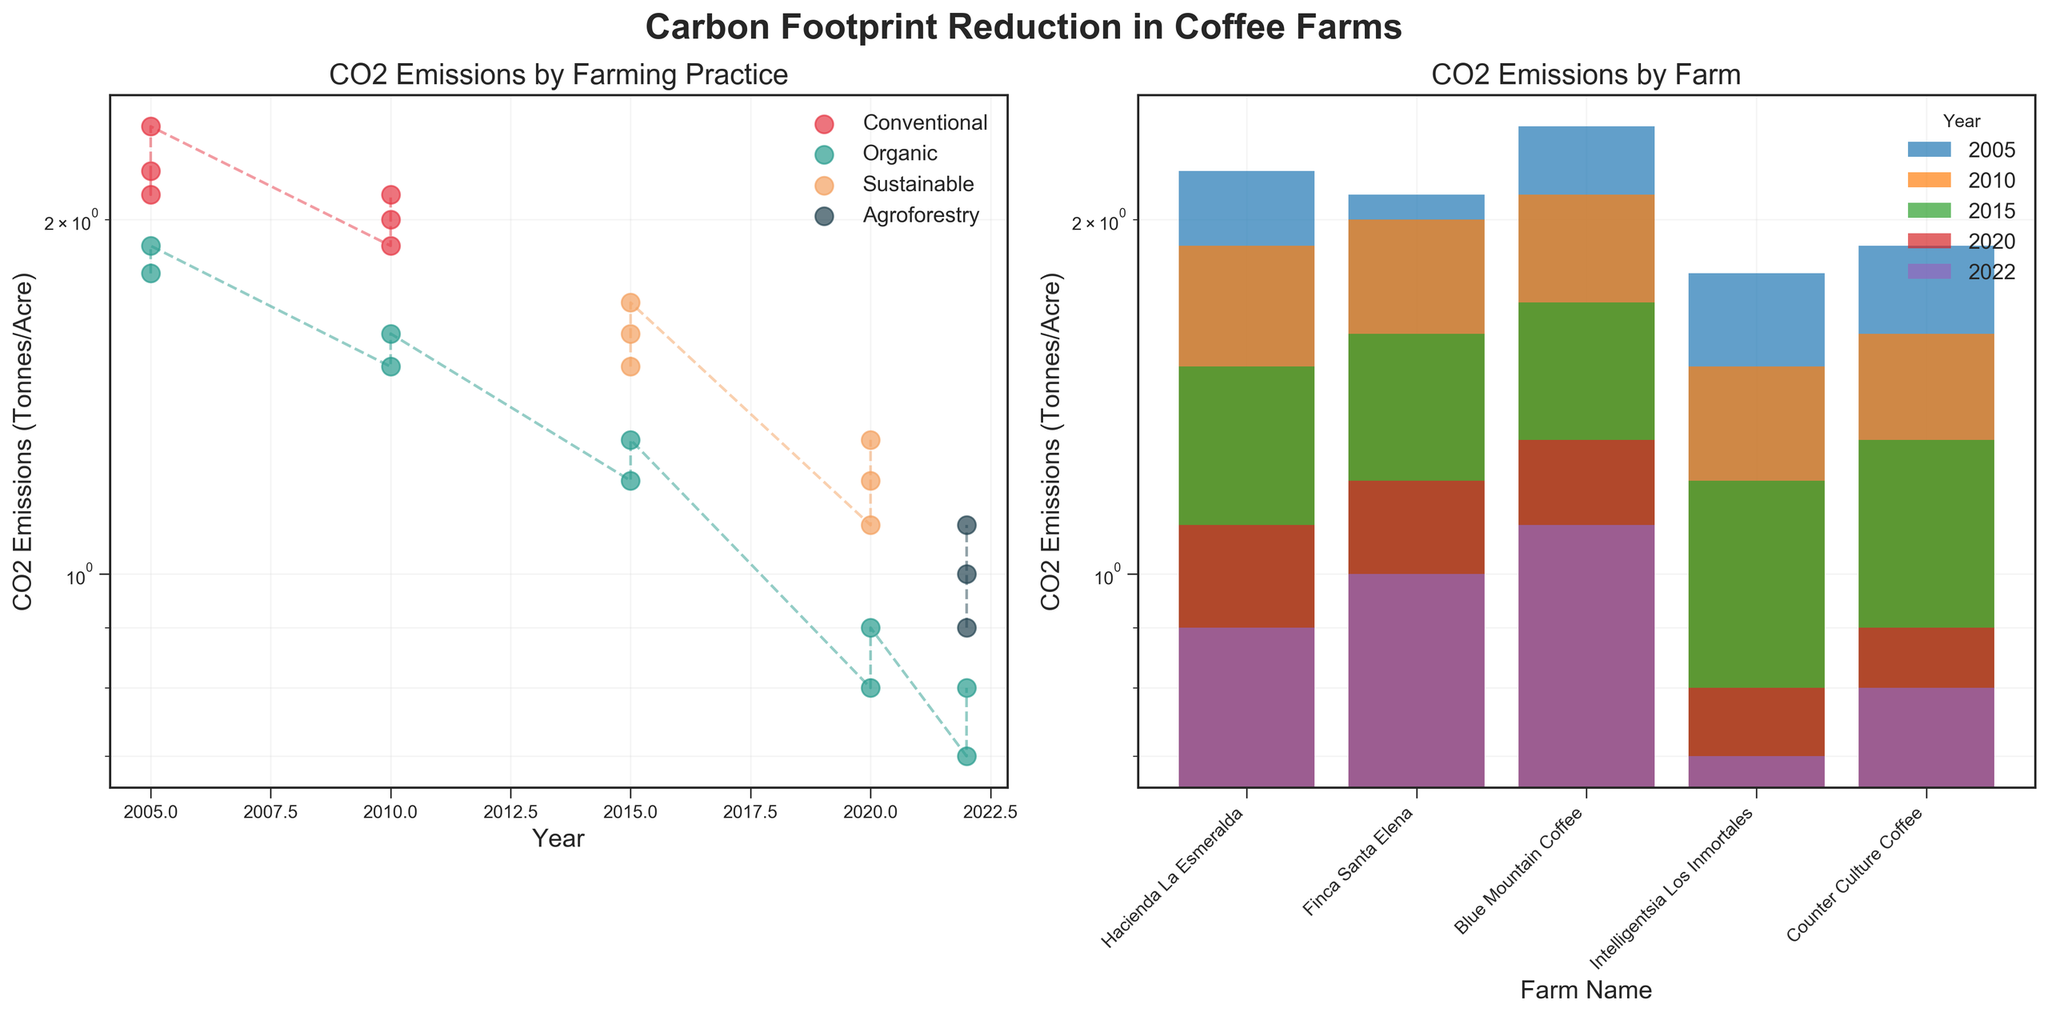What is the title of the left subplot? The title of the left subplot is "CO2 Emissions by Farming Practice," which indicates the CO2 emissions over the years categorized by different farming practices.
Answer: CO2 Emissions by Farming Practice Which farming practice consistently shows the lowest CO2 emissions in 2022? In 2022, 'Organic' farming practice consistently shows the lowest CO2 emissions, which can be observed by the position of the green dots and bars in the left and right subplots respectively.
Answer: Organic Between 2005 and 2022, which farming practice showed the most significant reduction in CO2 emissions? To find the farming practice with the most significant reduction, compare the initial and final values of CO2 emissions for each practice over the years. 'Conventional' and 'Sustainable' started higher but it's the 'Agroforestry' practice which showed a significant drop from when it was introduced in 2022.
Answer: Agroforestry How did CO2 emissions for 'Hacienda La Esmeralda' change from 2005 to 2022? For 'Hacienda La Esmeralda,' start with the CO2 emissions in 2005, which was under 'Conventional' farming practice, then follow the trend line through 'Sustainable' and 'Agroforestry' practices until 2022. The emissions decreased from 2.2 tonnes/acre in 2005 to 0.9 tonnes/acre in 2022.
Answer: Decreased from 2.2 to 0.9 tonnes/acre In which year did both 'Hacienda La Esmeralda' and 'Blue Mountain Coffee' have the same CO2 emissions, and what were the values? Check each year’s bar chart for when 'Hacienda La Esmeralda' and 'Blue Mountain Coffee' bars align at the same height. In 2015, both farms had CO2 emissions values of 1.5 tonnes/acre.
Answer: 2015, 1.5 tonnes/acre What is the general trend of CO2 emissions across all farming practices from 2005 to 2022? Observe the overall position and slope of lines and scatter points across the years from left to right. There is a consistent downward trend in CO2 emissions for all farming practices from 2005 to 2022, indicating a reduction over the years.
Answer: Downward trend Which farm had the highest CO2 emissions in 2005 and what was the value? On the right subplot, locate the year 2005 and identify the tallest bar. 'Blue Mountain Coffee' in 2005 had the highest CO2 emissions, with a value of 2.4 tonnes/acre.
Answer: Blue Mountain Coffee, 2.4 tonnes/acre In what year did 'Sustainable' farming practices first appear in the data, and what emission values did they have for the farms? On the left subplot, find the first year 'Sustainable' is listed in the legend and check the corresponding coordinates. 'Sustainable' first appeared in 2015 with emission values of 1.5, 1.6, and 1.7 tonnes/acre for the three farms listed.
Answer: 2015, 1.5, 1.6, 1.7 tonnes/acre Which farm experienced the largest single-year drop in CO2 emissions, looking at any consecutive pairs of years? Compare the vertical distances between points for each farm over the years. 'Hacienda La Esmeralda' showed the largest drop from 2015 to 2020, going from 1.5 to 1.1 tonnes/acre (0.4 tonnes/acre drop).
Answer: Hacienda La Esmeralda How do the CO2 emissions from 'Agroforestry' in 2022 compare to the average emissions from 'Conventional' farming in 2005? Calculate the average CO2 emissions for 'Conventional' farming in 2005, which includes 2.2, 2.1, and 2.4, totaling (2.2+2.1+2.4)/3 = 2.23 tonnes/acre. Compare this to the 'Agroforestry' values in 2022. Agroforestry (0.9, 1.0, 1.1) is significantly lower.
Answer: Agroforestry is lower; Average Conventional in 2005: 2.23; Agroforestry in 2022: (0.9, 1.0, 1.1) 